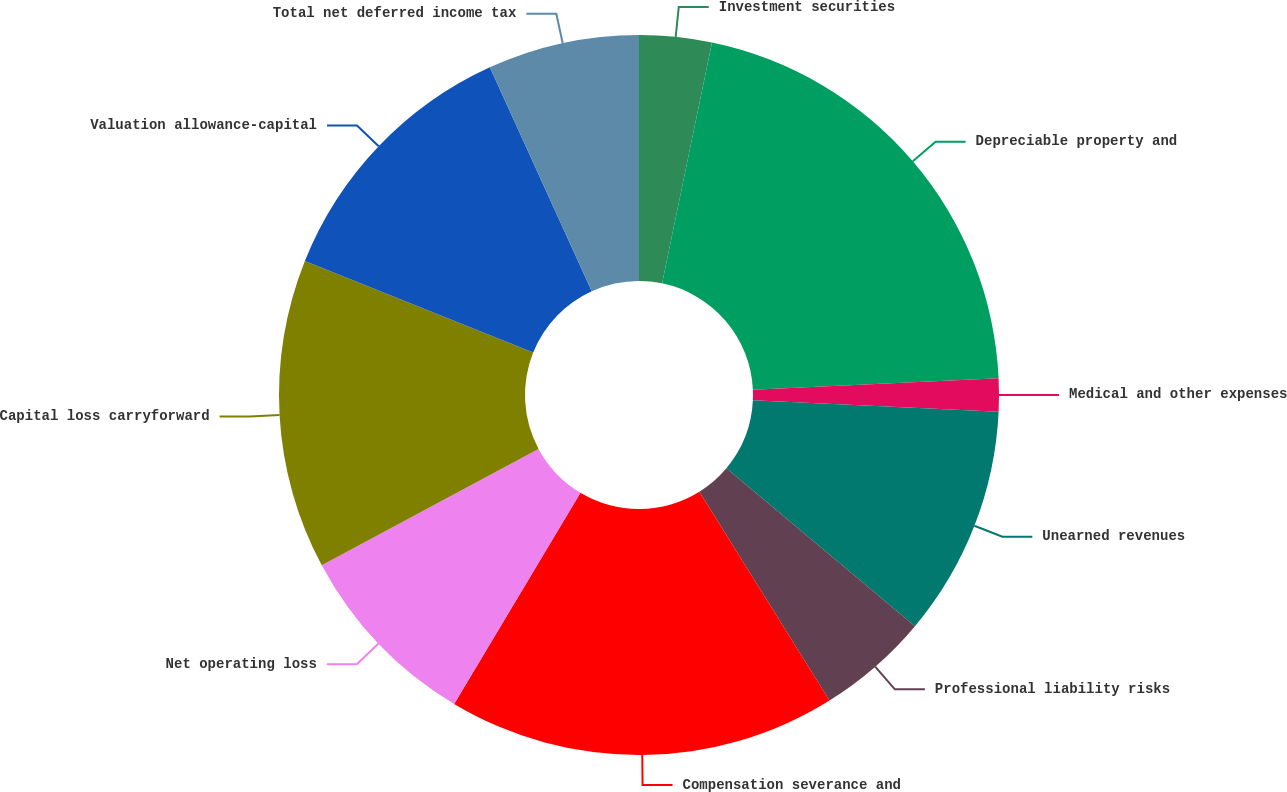Convert chart. <chart><loc_0><loc_0><loc_500><loc_500><pie_chart><fcel>Investment securities<fcel>Depreciable property and<fcel>Medical and other expenses<fcel>Unearned revenues<fcel>Professional liability risks<fcel>Compensation severance and<fcel>Net operating loss<fcel>Capital loss carryforward<fcel>Valuation allowance-capital<fcel>Total net deferred income tax<nl><fcel>3.25%<fcel>21.01%<fcel>1.48%<fcel>10.36%<fcel>5.03%<fcel>17.46%<fcel>8.58%<fcel>13.91%<fcel>12.13%<fcel>6.8%<nl></chart> 